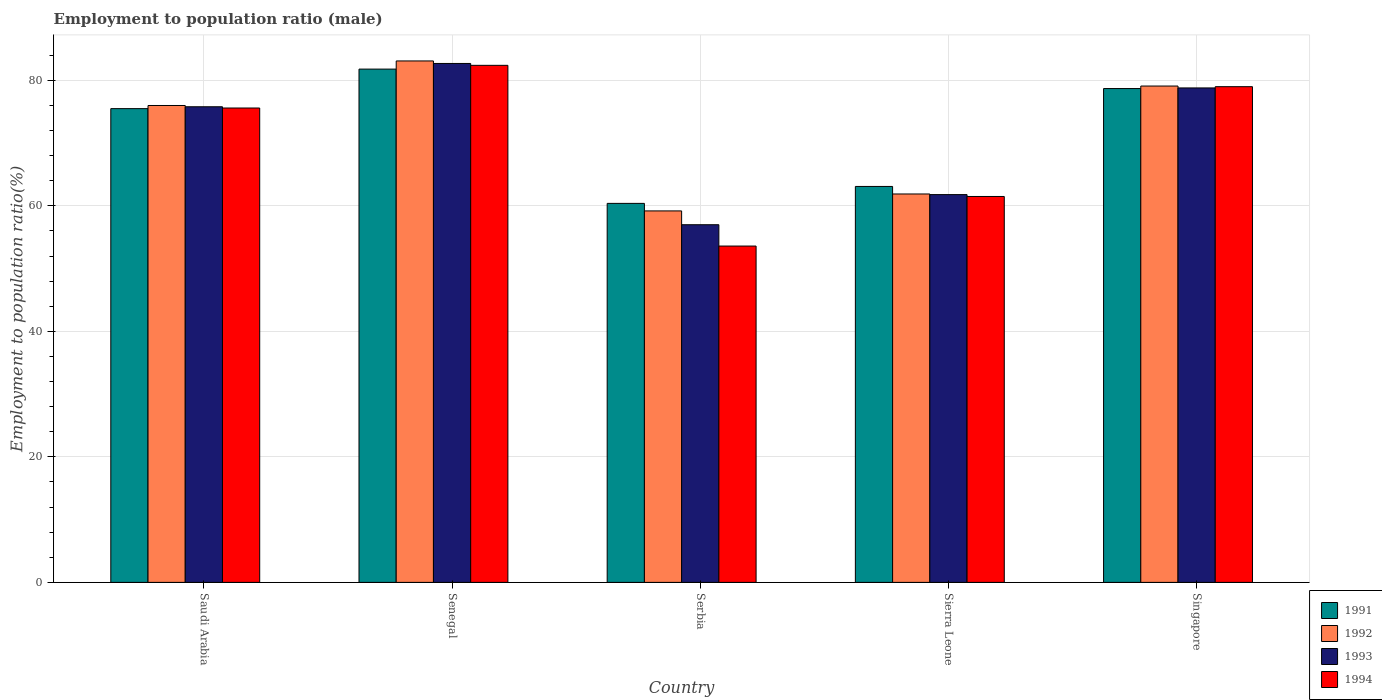How many different coloured bars are there?
Ensure brevity in your answer.  4. How many groups of bars are there?
Offer a very short reply. 5. How many bars are there on the 1st tick from the right?
Make the answer very short. 4. What is the label of the 5th group of bars from the left?
Give a very brief answer. Singapore. What is the employment to population ratio in 1993 in Saudi Arabia?
Offer a terse response. 75.8. Across all countries, what is the maximum employment to population ratio in 1992?
Offer a very short reply. 83.1. Across all countries, what is the minimum employment to population ratio in 1992?
Your answer should be very brief. 59.2. In which country was the employment to population ratio in 1994 maximum?
Keep it short and to the point. Senegal. In which country was the employment to population ratio in 1991 minimum?
Offer a terse response. Serbia. What is the total employment to population ratio in 1993 in the graph?
Offer a terse response. 356.1. What is the difference between the employment to population ratio in 1994 in Senegal and that in Sierra Leone?
Ensure brevity in your answer.  20.9. What is the difference between the employment to population ratio in 1993 in Serbia and the employment to population ratio in 1994 in Senegal?
Your answer should be compact. -25.4. What is the average employment to population ratio in 1991 per country?
Keep it short and to the point. 71.9. What is the difference between the employment to population ratio of/in 1993 and employment to population ratio of/in 1994 in Saudi Arabia?
Your answer should be very brief. 0.2. In how many countries, is the employment to population ratio in 1991 greater than 56 %?
Ensure brevity in your answer.  5. What is the ratio of the employment to population ratio in 1993 in Senegal to that in Serbia?
Offer a very short reply. 1.45. What is the difference between the highest and the second highest employment to population ratio in 1991?
Provide a succinct answer. 6.3. What is the difference between the highest and the lowest employment to population ratio in 1993?
Give a very brief answer. 25.7. In how many countries, is the employment to population ratio in 1994 greater than the average employment to population ratio in 1994 taken over all countries?
Provide a short and direct response. 3. Is the sum of the employment to population ratio in 1994 in Senegal and Singapore greater than the maximum employment to population ratio in 1992 across all countries?
Offer a very short reply. Yes. Is it the case that in every country, the sum of the employment to population ratio in 1991 and employment to population ratio in 1993 is greater than the sum of employment to population ratio in 1994 and employment to population ratio in 1992?
Give a very brief answer. No. How many bars are there?
Give a very brief answer. 20. Are the values on the major ticks of Y-axis written in scientific E-notation?
Your answer should be very brief. No. Does the graph contain any zero values?
Keep it short and to the point. No. Does the graph contain grids?
Your response must be concise. Yes. What is the title of the graph?
Your answer should be compact. Employment to population ratio (male). Does "2009" appear as one of the legend labels in the graph?
Offer a very short reply. No. What is the label or title of the Y-axis?
Keep it short and to the point. Employment to population ratio(%). What is the Employment to population ratio(%) of 1991 in Saudi Arabia?
Offer a very short reply. 75.5. What is the Employment to population ratio(%) in 1992 in Saudi Arabia?
Offer a terse response. 76. What is the Employment to population ratio(%) of 1993 in Saudi Arabia?
Ensure brevity in your answer.  75.8. What is the Employment to population ratio(%) in 1994 in Saudi Arabia?
Keep it short and to the point. 75.6. What is the Employment to population ratio(%) of 1991 in Senegal?
Provide a succinct answer. 81.8. What is the Employment to population ratio(%) in 1992 in Senegal?
Offer a very short reply. 83.1. What is the Employment to population ratio(%) of 1993 in Senegal?
Offer a terse response. 82.7. What is the Employment to population ratio(%) of 1994 in Senegal?
Make the answer very short. 82.4. What is the Employment to population ratio(%) in 1991 in Serbia?
Your response must be concise. 60.4. What is the Employment to population ratio(%) in 1992 in Serbia?
Keep it short and to the point. 59.2. What is the Employment to population ratio(%) of 1994 in Serbia?
Offer a terse response. 53.6. What is the Employment to population ratio(%) of 1991 in Sierra Leone?
Make the answer very short. 63.1. What is the Employment to population ratio(%) in 1992 in Sierra Leone?
Your answer should be compact. 61.9. What is the Employment to population ratio(%) of 1993 in Sierra Leone?
Make the answer very short. 61.8. What is the Employment to population ratio(%) of 1994 in Sierra Leone?
Make the answer very short. 61.5. What is the Employment to population ratio(%) in 1991 in Singapore?
Offer a terse response. 78.7. What is the Employment to population ratio(%) of 1992 in Singapore?
Provide a short and direct response. 79.1. What is the Employment to population ratio(%) of 1993 in Singapore?
Give a very brief answer. 78.8. What is the Employment to population ratio(%) in 1994 in Singapore?
Your response must be concise. 79. Across all countries, what is the maximum Employment to population ratio(%) in 1991?
Give a very brief answer. 81.8. Across all countries, what is the maximum Employment to population ratio(%) in 1992?
Keep it short and to the point. 83.1. Across all countries, what is the maximum Employment to population ratio(%) of 1993?
Provide a succinct answer. 82.7. Across all countries, what is the maximum Employment to population ratio(%) in 1994?
Your answer should be compact. 82.4. Across all countries, what is the minimum Employment to population ratio(%) of 1991?
Provide a short and direct response. 60.4. Across all countries, what is the minimum Employment to population ratio(%) of 1992?
Offer a very short reply. 59.2. Across all countries, what is the minimum Employment to population ratio(%) in 1993?
Provide a short and direct response. 57. Across all countries, what is the minimum Employment to population ratio(%) of 1994?
Make the answer very short. 53.6. What is the total Employment to population ratio(%) in 1991 in the graph?
Offer a terse response. 359.5. What is the total Employment to population ratio(%) of 1992 in the graph?
Offer a terse response. 359.3. What is the total Employment to population ratio(%) of 1993 in the graph?
Your answer should be compact. 356.1. What is the total Employment to population ratio(%) in 1994 in the graph?
Your answer should be very brief. 352.1. What is the difference between the Employment to population ratio(%) of 1991 in Saudi Arabia and that in Senegal?
Offer a terse response. -6.3. What is the difference between the Employment to population ratio(%) in 1992 in Saudi Arabia and that in Senegal?
Keep it short and to the point. -7.1. What is the difference between the Employment to population ratio(%) in 1994 in Saudi Arabia and that in Senegal?
Offer a terse response. -6.8. What is the difference between the Employment to population ratio(%) of 1992 in Saudi Arabia and that in Serbia?
Your response must be concise. 16.8. What is the difference between the Employment to population ratio(%) in 1992 in Saudi Arabia and that in Sierra Leone?
Offer a very short reply. 14.1. What is the difference between the Employment to population ratio(%) of 1993 in Saudi Arabia and that in Sierra Leone?
Your answer should be very brief. 14. What is the difference between the Employment to population ratio(%) in 1994 in Saudi Arabia and that in Sierra Leone?
Offer a terse response. 14.1. What is the difference between the Employment to population ratio(%) of 1991 in Saudi Arabia and that in Singapore?
Offer a very short reply. -3.2. What is the difference between the Employment to population ratio(%) in 1992 in Saudi Arabia and that in Singapore?
Your answer should be very brief. -3.1. What is the difference between the Employment to population ratio(%) of 1993 in Saudi Arabia and that in Singapore?
Ensure brevity in your answer.  -3. What is the difference between the Employment to population ratio(%) of 1994 in Saudi Arabia and that in Singapore?
Your response must be concise. -3.4. What is the difference between the Employment to population ratio(%) of 1991 in Senegal and that in Serbia?
Ensure brevity in your answer.  21.4. What is the difference between the Employment to population ratio(%) of 1992 in Senegal and that in Serbia?
Keep it short and to the point. 23.9. What is the difference between the Employment to population ratio(%) in 1993 in Senegal and that in Serbia?
Your answer should be very brief. 25.7. What is the difference between the Employment to population ratio(%) of 1994 in Senegal and that in Serbia?
Make the answer very short. 28.8. What is the difference between the Employment to population ratio(%) of 1991 in Senegal and that in Sierra Leone?
Make the answer very short. 18.7. What is the difference between the Employment to population ratio(%) of 1992 in Senegal and that in Sierra Leone?
Keep it short and to the point. 21.2. What is the difference between the Employment to population ratio(%) in 1993 in Senegal and that in Sierra Leone?
Your answer should be compact. 20.9. What is the difference between the Employment to population ratio(%) of 1994 in Senegal and that in Sierra Leone?
Provide a succinct answer. 20.9. What is the difference between the Employment to population ratio(%) in 1993 in Senegal and that in Singapore?
Your answer should be very brief. 3.9. What is the difference between the Employment to population ratio(%) in 1991 in Serbia and that in Sierra Leone?
Keep it short and to the point. -2.7. What is the difference between the Employment to population ratio(%) of 1992 in Serbia and that in Sierra Leone?
Provide a short and direct response. -2.7. What is the difference between the Employment to population ratio(%) in 1991 in Serbia and that in Singapore?
Give a very brief answer. -18.3. What is the difference between the Employment to population ratio(%) in 1992 in Serbia and that in Singapore?
Offer a terse response. -19.9. What is the difference between the Employment to population ratio(%) of 1993 in Serbia and that in Singapore?
Provide a short and direct response. -21.8. What is the difference between the Employment to population ratio(%) of 1994 in Serbia and that in Singapore?
Give a very brief answer. -25.4. What is the difference between the Employment to population ratio(%) of 1991 in Sierra Leone and that in Singapore?
Provide a short and direct response. -15.6. What is the difference between the Employment to population ratio(%) in 1992 in Sierra Leone and that in Singapore?
Provide a short and direct response. -17.2. What is the difference between the Employment to population ratio(%) of 1994 in Sierra Leone and that in Singapore?
Offer a very short reply. -17.5. What is the difference between the Employment to population ratio(%) of 1991 in Saudi Arabia and the Employment to population ratio(%) of 1992 in Senegal?
Ensure brevity in your answer.  -7.6. What is the difference between the Employment to population ratio(%) of 1991 in Saudi Arabia and the Employment to population ratio(%) of 1993 in Senegal?
Your answer should be very brief. -7.2. What is the difference between the Employment to population ratio(%) of 1992 in Saudi Arabia and the Employment to population ratio(%) of 1993 in Senegal?
Provide a short and direct response. -6.7. What is the difference between the Employment to population ratio(%) in 1991 in Saudi Arabia and the Employment to population ratio(%) in 1994 in Serbia?
Ensure brevity in your answer.  21.9. What is the difference between the Employment to population ratio(%) of 1992 in Saudi Arabia and the Employment to population ratio(%) of 1993 in Serbia?
Provide a short and direct response. 19. What is the difference between the Employment to population ratio(%) in 1992 in Saudi Arabia and the Employment to population ratio(%) in 1994 in Serbia?
Make the answer very short. 22.4. What is the difference between the Employment to population ratio(%) of 1991 in Saudi Arabia and the Employment to population ratio(%) of 1992 in Sierra Leone?
Give a very brief answer. 13.6. What is the difference between the Employment to population ratio(%) in 1993 in Saudi Arabia and the Employment to population ratio(%) in 1994 in Sierra Leone?
Offer a terse response. 14.3. What is the difference between the Employment to population ratio(%) of 1992 in Saudi Arabia and the Employment to population ratio(%) of 1993 in Singapore?
Your answer should be compact. -2.8. What is the difference between the Employment to population ratio(%) in 1991 in Senegal and the Employment to population ratio(%) in 1992 in Serbia?
Offer a very short reply. 22.6. What is the difference between the Employment to population ratio(%) in 1991 in Senegal and the Employment to population ratio(%) in 1993 in Serbia?
Your answer should be compact. 24.8. What is the difference between the Employment to population ratio(%) of 1991 in Senegal and the Employment to population ratio(%) of 1994 in Serbia?
Ensure brevity in your answer.  28.2. What is the difference between the Employment to population ratio(%) in 1992 in Senegal and the Employment to population ratio(%) in 1993 in Serbia?
Provide a succinct answer. 26.1. What is the difference between the Employment to population ratio(%) of 1992 in Senegal and the Employment to population ratio(%) of 1994 in Serbia?
Ensure brevity in your answer.  29.5. What is the difference between the Employment to population ratio(%) of 1993 in Senegal and the Employment to population ratio(%) of 1994 in Serbia?
Make the answer very short. 29.1. What is the difference between the Employment to population ratio(%) of 1991 in Senegal and the Employment to population ratio(%) of 1992 in Sierra Leone?
Provide a short and direct response. 19.9. What is the difference between the Employment to population ratio(%) of 1991 in Senegal and the Employment to population ratio(%) of 1993 in Sierra Leone?
Your answer should be compact. 20. What is the difference between the Employment to population ratio(%) in 1991 in Senegal and the Employment to population ratio(%) in 1994 in Sierra Leone?
Make the answer very short. 20.3. What is the difference between the Employment to population ratio(%) of 1992 in Senegal and the Employment to population ratio(%) of 1993 in Sierra Leone?
Your answer should be very brief. 21.3. What is the difference between the Employment to population ratio(%) in 1992 in Senegal and the Employment to population ratio(%) in 1994 in Sierra Leone?
Offer a terse response. 21.6. What is the difference between the Employment to population ratio(%) in 1993 in Senegal and the Employment to population ratio(%) in 1994 in Sierra Leone?
Your response must be concise. 21.2. What is the difference between the Employment to population ratio(%) of 1991 in Senegal and the Employment to population ratio(%) of 1992 in Singapore?
Provide a succinct answer. 2.7. What is the difference between the Employment to population ratio(%) in 1991 in Senegal and the Employment to population ratio(%) in 1993 in Singapore?
Your answer should be compact. 3. What is the difference between the Employment to population ratio(%) of 1992 in Senegal and the Employment to population ratio(%) of 1993 in Singapore?
Provide a short and direct response. 4.3. What is the difference between the Employment to population ratio(%) in 1992 in Senegal and the Employment to population ratio(%) in 1994 in Singapore?
Offer a very short reply. 4.1. What is the difference between the Employment to population ratio(%) of 1992 in Serbia and the Employment to population ratio(%) of 1993 in Sierra Leone?
Ensure brevity in your answer.  -2.6. What is the difference between the Employment to population ratio(%) of 1993 in Serbia and the Employment to population ratio(%) of 1994 in Sierra Leone?
Ensure brevity in your answer.  -4.5. What is the difference between the Employment to population ratio(%) of 1991 in Serbia and the Employment to population ratio(%) of 1992 in Singapore?
Your answer should be very brief. -18.7. What is the difference between the Employment to population ratio(%) in 1991 in Serbia and the Employment to population ratio(%) in 1993 in Singapore?
Offer a terse response. -18.4. What is the difference between the Employment to population ratio(%) of 1991 in Serbia and the Employment to population ratio(%) of 1994 in Singapore?
Give a very brief answer. -18.6. What is the difference between the Employment to population ratio(%) of 1992 in Serbia and the Employment to population ratio(%) of 1993 in Singapore?
Your answer should be compact. -19.6. What is the difference between the Employment to population ratio(%) of 1992 in Serbia and the Employment to population ratio(%) of 1994 in Singapore?
Offer a very short reply. -19.8. What is the difference between the Employment to population ratio(%) of 1991 in Sierra Leone and the Employment to population ratio(%) of 1992 in Singapore?
Your response must be concise. -16. What is the difference between the Employment to population ratio(%) of 1991 in Sierra Leone and the Employment to population ratio(%) of 1993 in Singapore?
Provide a succinct answer. -15.7. What is the difference between the Employment to population ratio(%) of 1991 in Sierra Leone and the Employment to population ratio(%) of 1994 in Singapore?
Keep it short and to the point. -15.9. What is the difference between the Employment to population ratio(%) in 1992 in Sierra Leone and the Employment to population ratio(%) in 1993 in Singapore?
Provide a short and direct response. -16.9. What is the difference between the Employment to population ratio(%) of 1992 in Sierra Leone and the Employment to population ratio(%) of 1994 in Singapore?
Give a very brief answer. -17.1. What is the difference between the Employment to population ratio(%) in 1993 in Sierra Leone and the Employment to population ratio(%) in 1994 in Singapore?
Provide a succinct answer. -17.2. What is the average Employment to population ratio(%) in 1991 per country?
Your answer should be very brief. 71.9. What is the average Employment to population ratio(%) of 1992 per country?
Your answer should be very brief. 71.86. What is the average Employment to population ratio(%) of 1993 per country?
Offer a terse response. 71.22. What is the average Employment to population ratio(%) in 1994 per country?
Your response must be concise. 70.42. What is the difference between the Employment to population ratio(%) of 1992 and Employment to population ratio(%) of 1993 in Saudi Arabia?
Make the answer very short. 0.2. What is the difference between the Employment to population ratio(%) of 1991 and Employment to population ratio(%) of 1992 in Senegal?
Ensure brevity in your answer.  -1.3. What is the difference between the Employment to population ratio(%) in 1991 and Employment to population ratio(%) in 1993 in Senegal?
Make the answer very short. -0.9. What is the difference between the Employment to population ratio(%) in 1991 and Employment to population ratio(%) in 1994 in Senegal?
Offer a very short reply. -0.6. What is the difference between the Employment to population ratio(%) of 1992 and Employment to population ratio(%) of 1994 in Senegal?
Provide a succinct answer. 0.7. What is the difference between the Employment to population ratio(%) of 1993 and Employment to population ratio(%) of 1994 in Senegal?
Your response must be concise. 0.3. What is the difference between the Employment to population ratio(%) of 1991 and Employment to population ratio(%) of 1992 in Serbia?
Provide a succinct answer. 1.2. What is the difference between the Employment to population ratio(%) of 1992 and Employment to population ratio(%) of 1993 in Serbia?
Your answer should be compact. 2.2. What is the difference between the Employment to population ratio(%) of 1993 and Employment to population ratio(%) of 1994 in Serbia?
Offer a terse response. 3.4. What is the difference between the Employment to population ratio(%) in 1991 and Employment to population ratio(%) in 1994 in Sierra Leone?
Give a very brief answer. 1.6. What is the difference between the Employment to population ratio(%) in 1992 and Employment to population ratio(%) in 1993 in Sierra Leone?
Ensure brevity in your answer.  0.1. What is the difference between the Employment to population ratio(%) of 1992 and Employment to population ratio(%) of 1994 in Sierra Leone?
Keep it short and to the point. 0.4. What is the difference between the Employment to population ratio(%) in 1991 and Employment to population ratio(%) in 1992 in Singapore?
Offer a terse response. -0.4. What is the difference between the Employment to population ratio(%) of 1992 and Employment to population ratio(%) of 1993 in Singapore?
Your answer should be compact. 0.3. What is the difference between the Employment to population ratio(%) in 1992 and Employment to population ratio(%) in 1994 in Singapore?
Provide a succinct answer. 0.1. What is the ratio of the Employment to population ratio(%) in 1991 in Saudi Arabia to that in Senegal?
Your response must be concise. 0.92. What is the ratio of the Employment to population ratio(%) of 1992 in Saudi Arabia to that in Senegal?
Your answer should be very brief. 0.91. What is the ratio of the Employment to population ratio(%) of 1993 in Saudi Arabia to that in Senegal?
Make the answer very short. 0.92. What is the ratio of the Employment to population ratio(%) of 1994 in Saudi Arabia to that in Senegal?
Offer a terse response. 0.92. What is the ratio of the Employment to population ratio(%) of 1991 in Saudi Arabia to that in Serbia?
Ensure brevity in your answer.  1.25. What is the ratio of the Employment to population ratio(%) in 1992 in Saudi Arabia to that in Serbia?
Your response must be concise. 1.28. What is the ratio of the Employment to population ratio(%) in 1993 in Saudi Arabia to that in Serbia?
Your response must be concise. 1.33. What is the ratio of the Employment to population ratio(%) in 1994 in Saudi Arabia to that in Serbia?
Make the answer very short. 1.41. What is the ratio of the Employment to population ratio(%) of 1991 in Saudi Arabia to that in Sierra Leone?
Provide a succinct answer. 1.2. What is the ratio of the Employment to population ratio(%) of 1992 in Saudi Arabia to that in Sierra Leone?
Your answer should be very brief. 1.23. What is the ratio of the Employment to population ratio(%) in 1993 in Saudi Arabia to that in Sierra Leone?
Offer a very short reply. 1.23. What is the ratio of the Employment to population ratio(%) in 1994 in Saudi Arabia to that in Sierra Leone?
Make the answer very short. 1.23. What is the ratio of the Employment to population ratio(%) in 1991 in Saudi Arabia to that in Singapore?
Ensure brevity in your answer.  0.96. What is the ratio of the Employment to population ratio(%) of 1992 in Saudi Arabia to that in Singapore?
Give a very brief answer. 0.96. What is the ratio of the Employment to population ratio(%) in 1993 in Saudi Arabia to that in Singapore?
Ensure brevity in your answer.  0.96. What is the ratio of the Employment to population ratio(%) in 1994 in Saudi Arabia to that in Singapore?
Provide a short and direct response. 0.96. What is the ratio of the Employment to population ratio(%) of 1991 in Senegal to that in Serbia?
Offer a very short reply. 1.35. What is the ratio of the Employment to population ratio(%) in 1992 in Senegal to that in Serbia?
Offer a very short reply. 1.4. What is the ratio of the Employment to population ratio(%) of 1993 in Senegal to that in Serbia?
Ensure brevity in your answer.  1.45. What is the ratio of the Employment to population ratio(%) in 1994 in Senegal to that in Serbia?
Give a very brief answer. 1.54. What is the ratio of the Employment to population ratio(%) in 1991 in Senegal to that in Sierra Leone?
Ensure brevity in your answer.  1.3. What is the ratio of the Employment to population ratio(%) in 1992 in Senegal to that in Sierra Leone?
Provide a succinct answer. 1.34. What is the ratio of the Employment to population ratio(%) in 1993 in Senegal to that in Sierra Leone?
Provide a succinct answer. 1.34. What is the ratio of the Employment to population ratio(%) of 1994 in Senegal to that in Sierra Leone?
Offer a very short reply. 1.34. What is the ratio of the Employment to population ratio(%) in 1991 in Senegal to that in Singapore?
Make the answer very short. 1.04. What is the ratio of the Employment to population ratio(%) of 1992 in Senegal to that in Singapore?
Offer a very short reply. 1.05. What is the ratio of the Employment to population ratio(%) of 1993 in Senegal to that in Singapore?
Ensure brevity in your answer.  1.05. What is the ratio of the Employment to population ratio(%) in 1994 in Senegal to that in Singapore?
Offer a very short reply. 1.04. What is the ratio of the Employment to population ratio(%) in 1991 in Serbia to that in Sierra Leone?
Provide a succinct answer. 0.96. What is the ratio of the Employment to population ratio(%) in 1992 in Serbia to that in Sierra Leone?
Offer a very short reply. 0.96. What is the ratio of the Employment to population ratio(%) in 1993 in Serbia to that in Sierra Leone?
Offer a very short reply. 0.92. What is the ratio of the Employment to population ratio(%) in 1994 in Serbia to that in Sierra Leone?
Provide a succinct answer. 0.87. What is the ratio of the Employment to population ratio(%) of 1991 in Serbia to that in Singapore?
Offer a very short reply. 0.77. What is the ratio of the Employment to population ratio(%) in 1992 in Serbia to that in Singapore?
Provide a short and direct response. 0.75. What is the ratio of the Employment to population ratio(%) of 1993 in Serbia to that in Singapore?
Ensure brevity in your answer.  0.72. What is the ratio of the Employment to population ratio(%) of 1994 in Serbia to that in Singapore?
Offer a very short reply. 0.68. What is the ratio of the Employment to population ratio(%) in 1991 in Sierra Leone to that in Singapore?
Keep it short and to the point. 0.8. What is the ratio of the Employment to population ratio(%) of 1992 in Sierra Leone to that in Singapore?
Offer a terse response. 0.78. What is the ratio of the Employment to population ratio(%) of 1993 in Sierra Leone to that in Singapore?
Provide a succinct answer. 0.78. What is the ratio of the Employment to population ratio(%) of 1994 in Sierra Leone to that in Singapore?
Your answer should be compact. 0.78. What is the difference between the highest and the second highest Employment to population ratio(%) of 1993?
Provide a succinct answer. 3.9. What is the difference between the highest and the second highest Employment to population ratio(%) in 1994?
Provide a succinct answer. 3.4. What is the difference between the highest and the lowest Employment to population ratio(%) in 1991?
Give a very brief answer. 21.4. What is the difference between the highest and the lowest Employment to population ratio(%) of 1992?
Ensure brevity in your answer.  23.9. What is the difference between the highest and the lowest Employment to population ratio(%) of 1993?
Ensure brevity in your answer.  25.7. What is the difference between the highest and the lowest Employment to population ratio(%) of 1994?
Your answer should be compact. 28.8. 